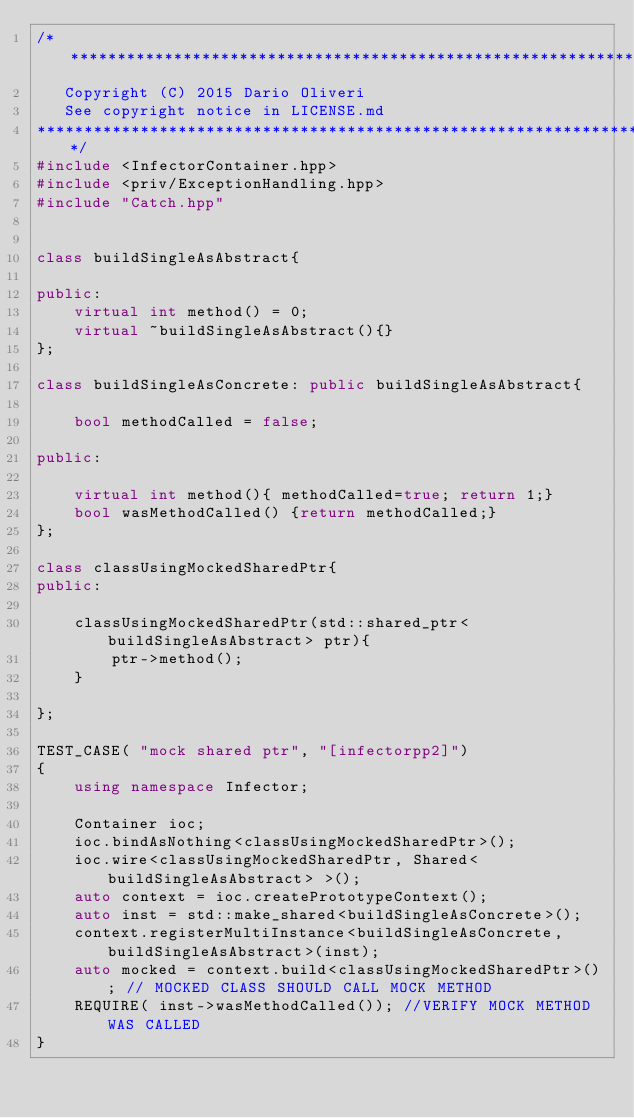Convert code to text. <code><loc_0><loc_0><loc_500><loc_500><_C++_>/*******************************************************************************
   Copyright (C) 2015 Dario Oliveri
   See copyright notice in LICENSE.md
*******************************************************************************/
#include <InfectorContainer.hpp>
#include <priv/ExceptionHandling.hpp>
#include "Catch.hpp"


class buildSingleAsAbstract{
	
public:
	virtual int method() = 0;
	virtual ~buildSingleAsAbstract(){}
};

class buildSingleAsConcrete: public buildSingleAsAbstract{
	
	bool methodCalled = false;
	
public:

	virtual int method(){ methodCalled=true; return 1;}
	bool wasMethodCalled() {return methodCalled;}
};

class classUsingMockedSharedPtr{
public:

	classUsingMockedSharedPtr(std::shared_ptr<buildSingleAsAbstract> ptr){
		ptr->method();
	}
	
};

TEST_CASE( "mock shared ptr", "[infectorpp2]")
{
	using namespace Infector;
	
	Container ioc;
	ioc.bindAsNothing<classUsingMockedSharedPtr>();
	ioc.wire<classUsingMockedSharedPtr, Shared<buildSingleAsAbstract> >();
	auto context = ioc.createPrototypeContext();
	auto inst = std::make_shared<buildSingleAsConcrete>();
	context.registerMultiInstance<buildSingleAsConcrete,  buildSingleAsAbstract>(inst);
	auto mocked = context.build<classUsingMockedSharedPtr>(); // MOCKED CLASS SHOULD CALL MOCK METHOD
	REQUIRE( inst->wasMethodCalled()); //VERIFY MOCK METHOD WAS CALLED
}</code> 